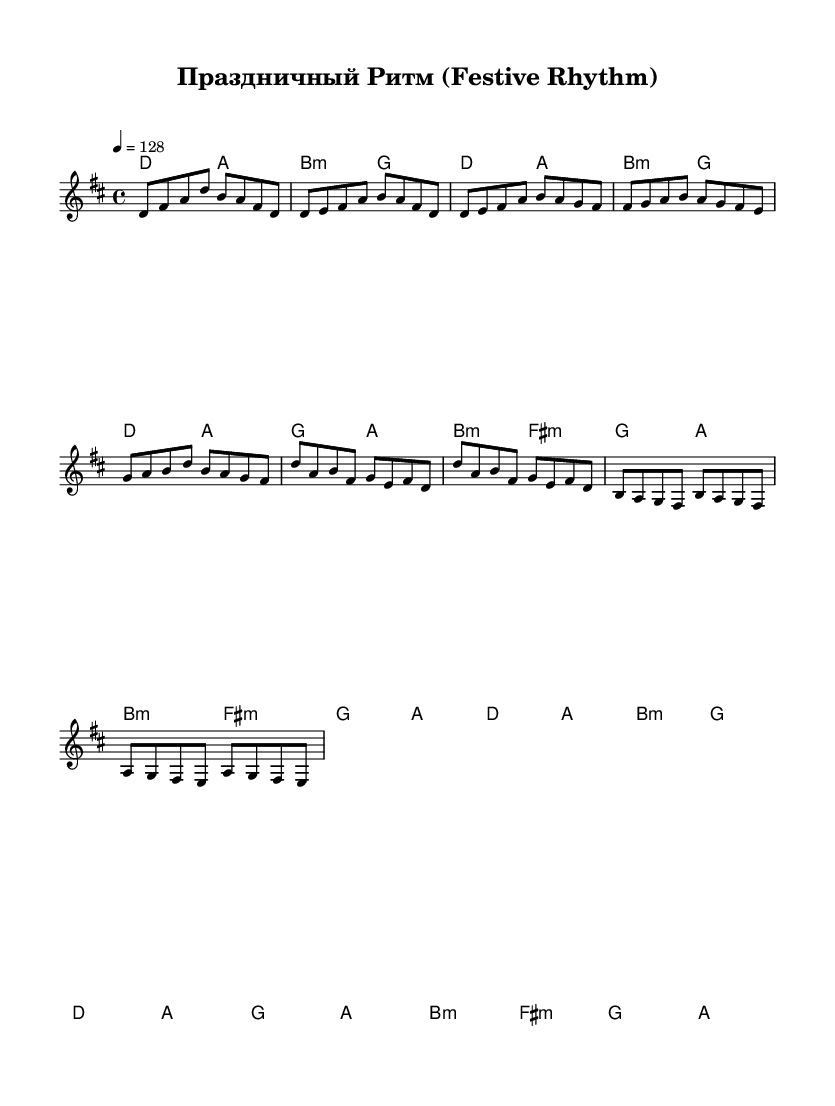What is the key signature of this music? The key signature is D major, which has two sharps (F# and C#). This can be inferred from the global section of the code where `\key d \major` is specified.
Answer: D major What is the time signature of this music? The time signature is 4/4, as indicated by the `\time 4/4` statement in the global section. This means there are four beats in a measure, and a quarter note receives one beat.
Answer: 4/4 What is the tempo of the piece? The tempo is 128 beats per minute, as shown in the `\tempo 4 = 128` line from the global section of the code. This means each quarter note is played at a speed of 128 beats per minute.
Answer: 128 How many measures are in the melody section? The melody section includes a total of 17 measures, counted directly from the melody definitions, where each distinct group of notes separated by the bar line counts as one measure.
Answer: 17 What type of harmony is primarily used in the chorus section? The harmony used in the chorus section is primarily D major and B minor, based on the chords provided in the `\chordmode` section, where the harmonic structure alternates between these two chords in the chorus measures.
Answer: D major and B minor What is the structure of this dance piece? The structure of this dance piece consists of an Intro, Verse, Pre-Chorus, Chorus, and Bridge, as clearly outlined by the labeled sections in the melody and harmonies indicating the flow of the composition.
Answer: Intro, Verse, Pre-Chorus, Chorus, Bridge 